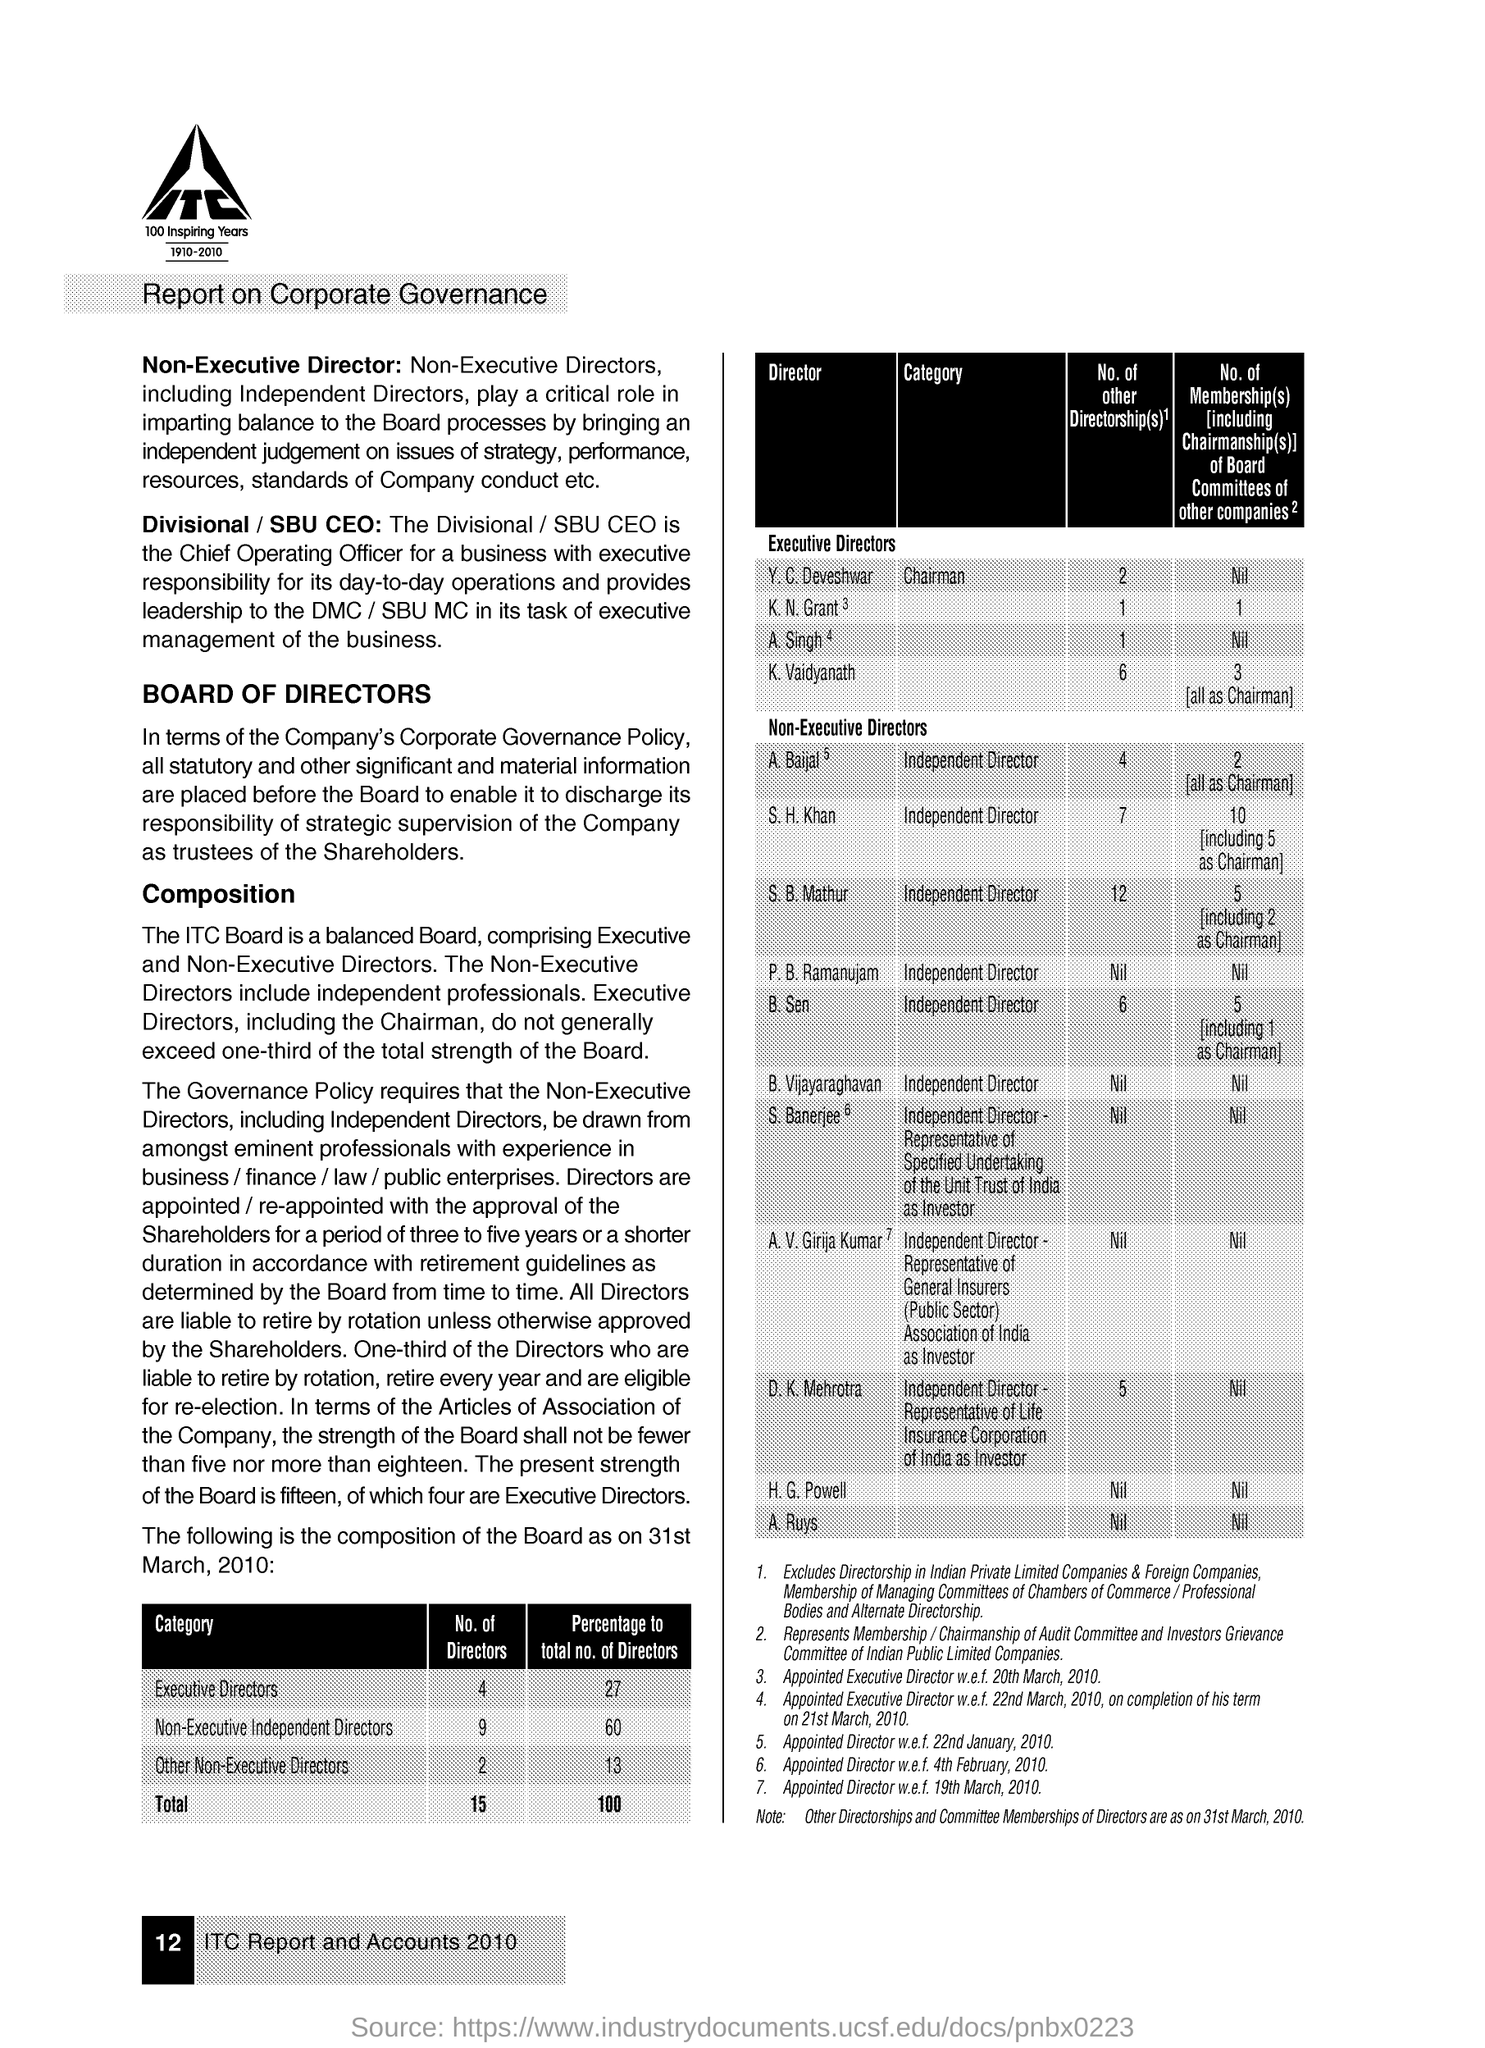How many Directors are there in the category of Executive Directors?
Your response must be concise. 4. 